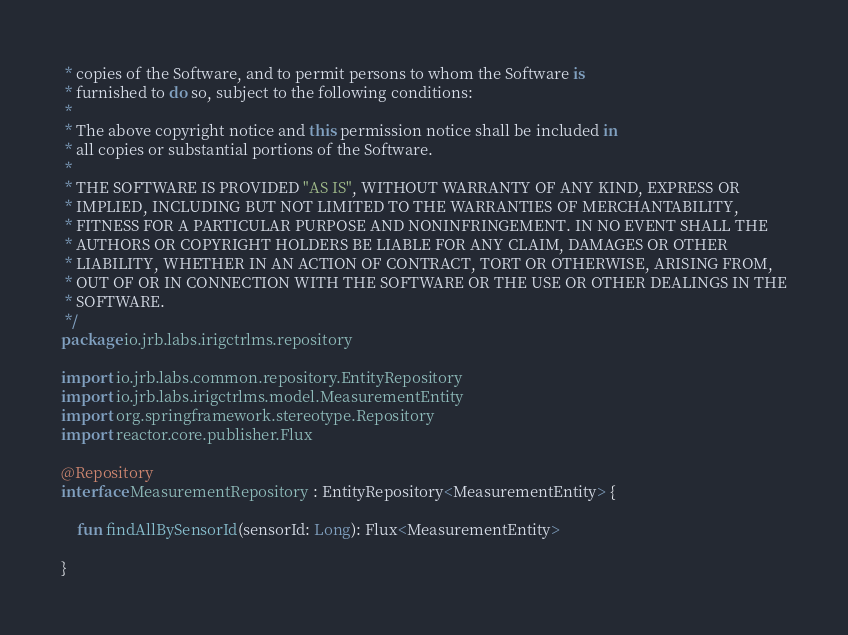<code> <loc_0><loc_0><loc_500><loc_500><_Kotlin_> * copies of the Software, and to permit persons to whom the Software is
 * furnished to do so, subject to the following conditions:
 *
 * The above copyright notice and this permission notice shall be included in
 * all copies or substantial portions of the Software.
 *
 * THE SOFTWARE IS PROVIDED "AS IS", WITHOUT WARRANTY OF ANY KIND, EXPRESS OR
 * IMPLIED, INCLUDING BUT NOT LIMITED TO THE WARRANTIES OF MERCHANTABILITY,
 * FITNESS FOR A PARTICULAR PURPOSE AND NONINFRINGEMENT. IN NO EVENT SHALL THE
 * AUTHORS OR COPYRIGHT HOLDERS BE LIABLE FOR ANY CLAIM, DAMAGES OR OTHER
 * LIABILITY, WHETHER IN AN ACTION OF CONTRACT, TORT OR OTHERWISE, ARISING FROM,
 * OUT OF OR IN CONNECTION WITH THE SOFTWARE OR THE USE OR OTHER DEALINGS IN THE
 * SOFTWARE.
 */
package io.jrb.labs.irigctrlms.repository

import io.jrb.labs.common.repository.EntityRepository
import io.jrb.labs.irigctrlms.model.MeasurementEntity
import org.springframework.stereotype.Repository
import reactor.core.publisher.Flux

@Repository
interface MeasurementRepository : EntityRepository<MeasurementEntity> {

    fun findAllBySensorId(sensorId: Long): Flux<MeasurementEntity>

}
</code> 